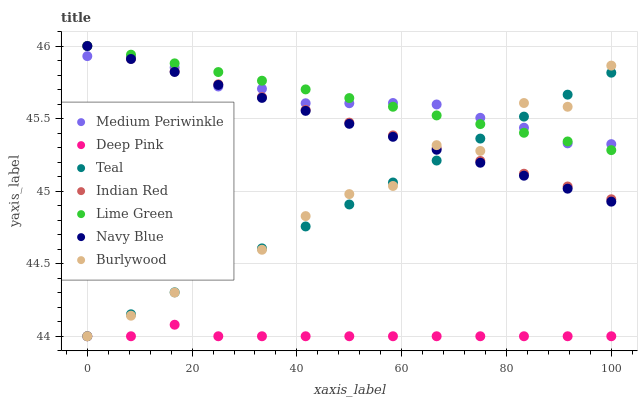Does Deep Pink have the minimum area under the curve?
Answer yes or no. Yes. Does Lime Green have the maximum area under the curve?
Answer yes or no. Yes. Does Teal have the minimum area under the curve?
Answer yes or no. No. Does Teal have the maximum area under the curve?
Answer yes or no. No. Is Indian Red the smoothest?
Answer yes or no. Yes. Is Burlywood the roughest?
Answer yes or no. Yes. Is Teal the smoothest?
Answer yes or no. No. Is Teal the roughest?
Answer yes or no. No. Does Deep Pink have the lowest value?
Answer yes or no. Yes. Does Navy Blue have the lowest value?
Answer yes or no. No. Does Lime Green have the highest value?
Answer yes or no. Yes. Does Teal have the highest value?
Answer yes or no. No. Is Deep Pink less than Medium Periwinkle?
Answer yes or no. Yes. Is Medium Periwinkle greater than Deep Pink?
Answer yes or no. Yes. Does Deep Pink intersect Teal?
Answer yes or no. Yes. Is Deep Pink less than Teal?
Answer yes or no. No. Is Deep Pink greater than Teal?
Answer yes or no. No. Does Deep Pink intersect Medium Periwinkle?
Answer yes or no. No. 